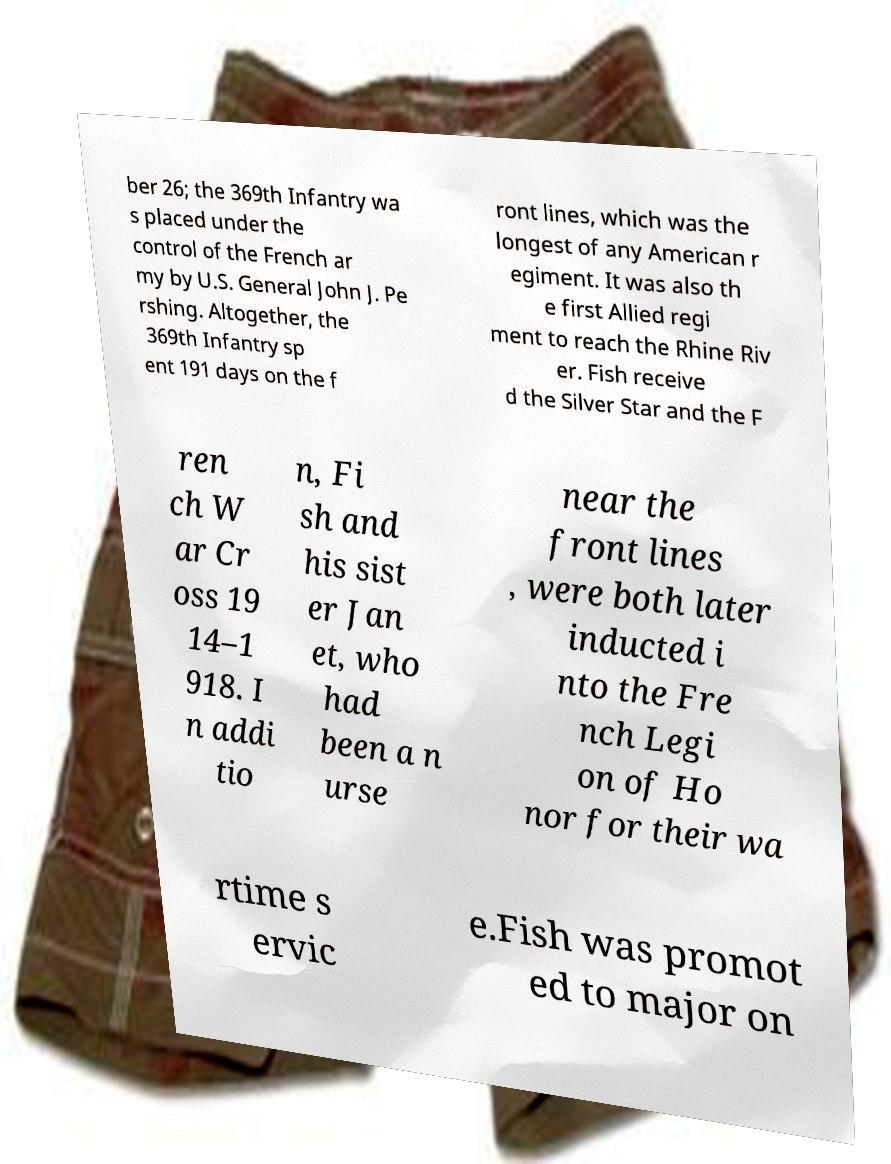Can you read and provide the text displayed in the image?This photo seems to have some interesting text. Can you extract and type it out for me? ber 26; the 369th Infantry wa s placed under the control of the French ar my by U.S. General John J. Pe rshing. Altogether, the 369th Infantry sp ent 191 days on the f ront lines, which was the longest of any American r egiment. It was also th e first Allied regi ment to reach the Rhine Riv er. Fish receive d the Silver Star and the F ren ch W ar Cr oss 19 14–1 918. I n addi tio n, Fi sh and his sist er Jan et, who had been a n urse near the front lines , were both later inducted i nto the Fre nch Legi on of Ho nor for their wa rtime s ervic e.Fish was promot ed to major on 